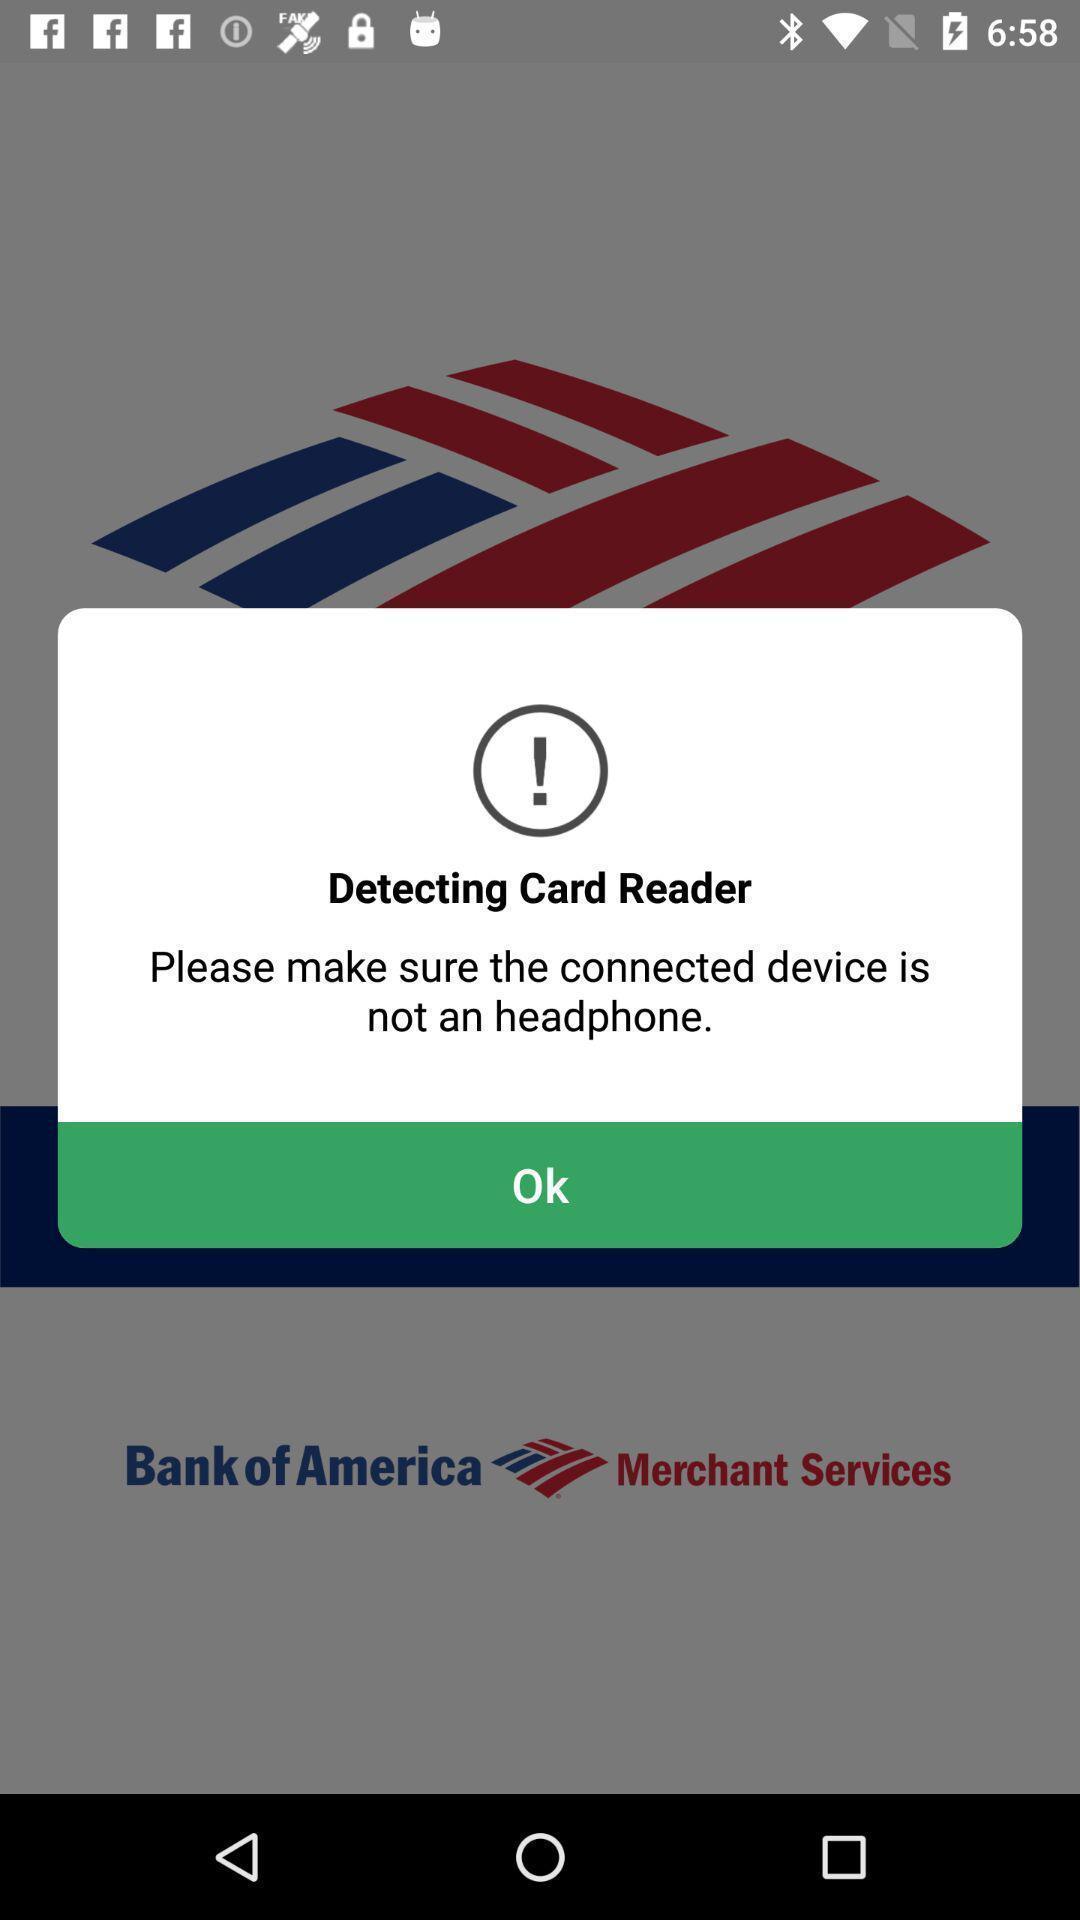Tell me about the visual elements in this screen capture. Warning message displaying to connect properly. 